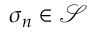Convert formula to latex. <formula><loc_0><loc_0><loc_500><loc_500>\sigma _ { n } \in \mathcal { S }</formula> 